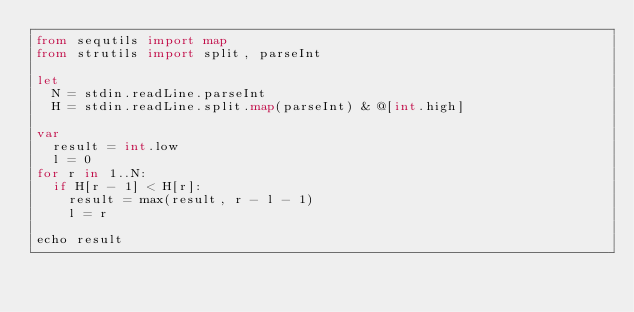Convert code to text. <code><loc_0><loc_0><loc_500><loc_500><_Nim_>from sequtils import map
from strutils import split, parseInt

let
  N = stdin.readLine.parseInt
  H = stdin.readLine.split.map(parseInt) & @[int.high]

var
  result = int.low
  l = 0
for r in 1..N:
  if H[r - 1] < H[r]:
    result = max(result, r - l - 1)
    l = r

echo result
</code> 